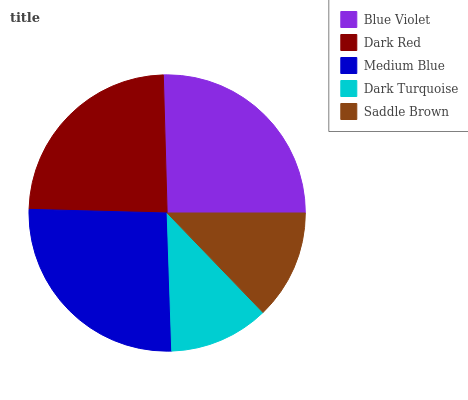Is Dark Turquoise the minimum?
Answer yes or no. Yes. Is Medium Blue the maximum?
Answer yes or no. Yes. Is Dark Red the minimum?
Answer yes or no. No. Is Dark Red the maximum?
Answer yes or no. No. Is Blue Violet greater than Dark Red?
Answer yes or no. Yes. Is Dark Red less than Blue Violet?
Answer yes or no. Yes. Is Dark Red greater than Blue Violet?
Answer yes or no. No. Is Blue Violet less than Dark Red?
Answer yes or no. No. Is Dark Red the high median?
Answer yes or no. Yes. Is Dark Red the low median?
Answer yes or no. Yes. Is Medium Blue the high median?
Answer yes or no. No. Is Dark Turquoise the low median?
Answer yes or no. No. 